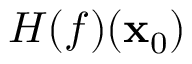<formula> <loc_0><loc_0><loc_500><loc_500>H ( f ) ( x _ { 0 } )</formula> 